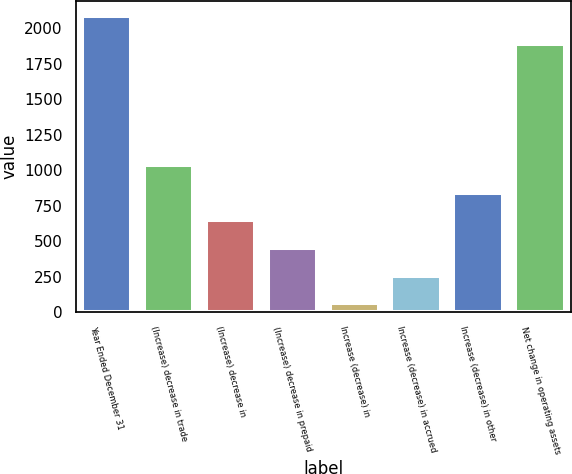<chart> <loc_0><loc_0><loc_500><loc_500><bar_chart><fcel>Year Ended December 31<fcel>(Increase) decrease in trade<fcel>(Increase) decrease in<fcel>(Increase) decrease in prepaid<fcel>Increase (decrease) in<fcel>Increase (decrease) in accrued<fcel>Increase (decrease) in other<fcel>Net change in operating assets<nl><fcel>2087.8<fcel>1037<fcel>647.4<fcel>452.6<fcel>63<fcel>257.8<fcel>842.2<fcel>1893<nl></chart> 